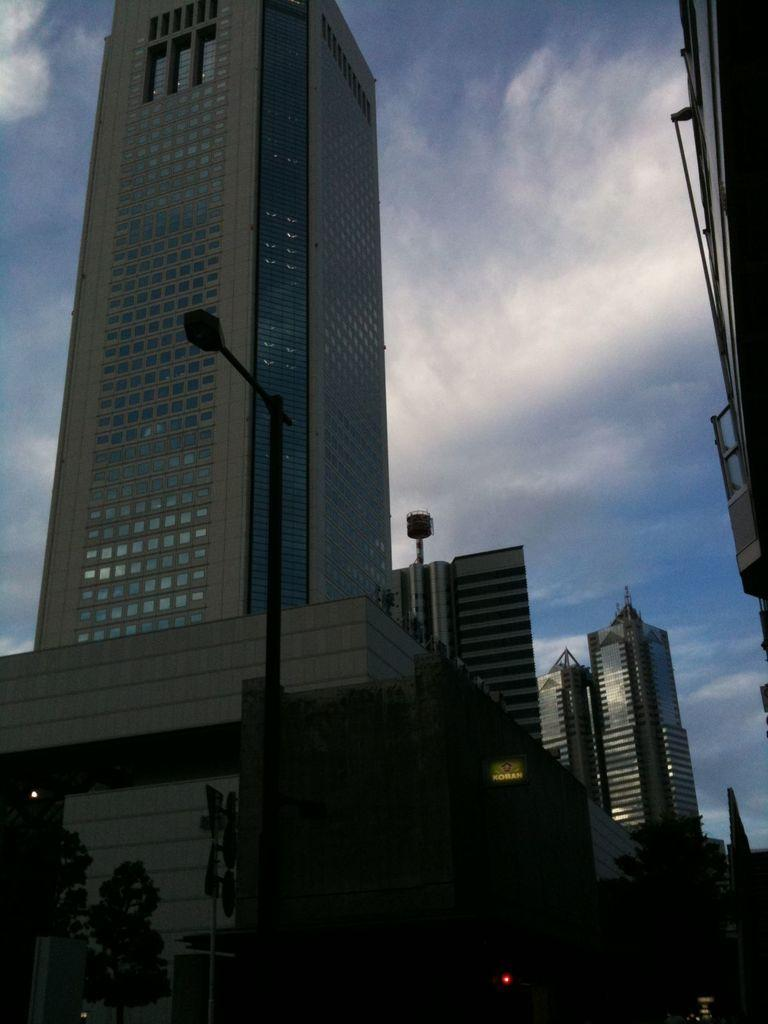What type of buildings are located in the middle of the image? There are skyscrapers in the middle of the image. What is in front of the skyscrapers? Trees are present in front of the skyscrapers. What can be seen on the road in the image? Vehicles are visible on the road in the image. What is visible above the skyscrapers? The sky is visible above the skyscrapers. Can you tell me what book the curtain is reading in the image? There is no curtain or book present in the image. What type of airport can be seen in the image? There is no airport visible in the image; it features skyscrapers, trees, vehicles, and the sky. 